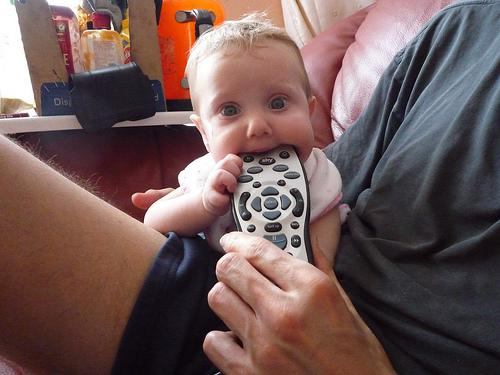Question: what is daddy wearing on the bottom?
Choices:
A. Shoes.
B. Shorts.
C. Jeans.
D. Slacks.
Answer with the letter. Answer: B Question: where is daddy sitting?
Choices:
A. On a recliner.
B. On a bench.
C. In a lawn chair.
D. In a barbers chair.
Answer with the letter. Answer: A Question: what is in the baby's mouth?
Choices:
A. A pacifier.
B. A remote control.
C. A bottle.
D. It's thumb.
Answer with the letter. Answer: B Question: what color is its hair?
Choices:
A. Brown.
B. Black.
C. Red.
D. Blonde.
Answer with the letter. Answer: D 